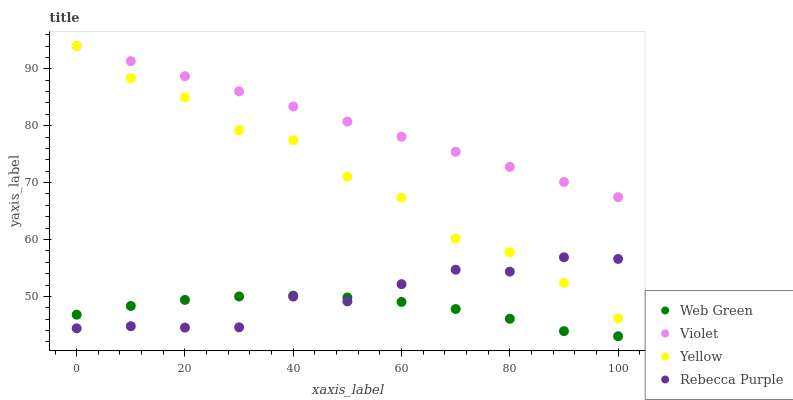Does Web Green have the minimum area under the curve?
Answer yes or no. Yes. Does Violet have the maximum area under the curve?
Answer yes or no. Yes. Does Yellow have the minimum area under the curve?
Answer yes or no. No. Does Yellow have the maximum area under the curve?
Answer yes or no. No. Is Violet the smoothest?
Answer yes or no. Yes. Is Yellow the roughest?
Answer yes or no. Yes. Is Web Green the smoothest?
Answer yes or no. No. Is Web Green the roughest?
Answer yes or no. No. Does Web Green have the lowest value?
Answer yes or no. Yes. Does Yellow have the lowest value?
Answer yes or no. No. Does Violet have the highest value?
Answer yes or no. Yes. Does Web Green have the highest value?
Answer yes or no. No. Is Web Green less than Violet?
Answer yes or no. Yes. Is Violet greater than Web Green?
Answer yes or no. Yes. Does Rebecca Purple intersect Web Green?
Answer yes or no. Yes. Is Rebecca Purple less than Web Green?
Answer yes or no. No. Is Rebecca Purple greater than Web Green?
Answer yes or no. No. Does Web Green intersect Violet?
Answer yes or no. No. 